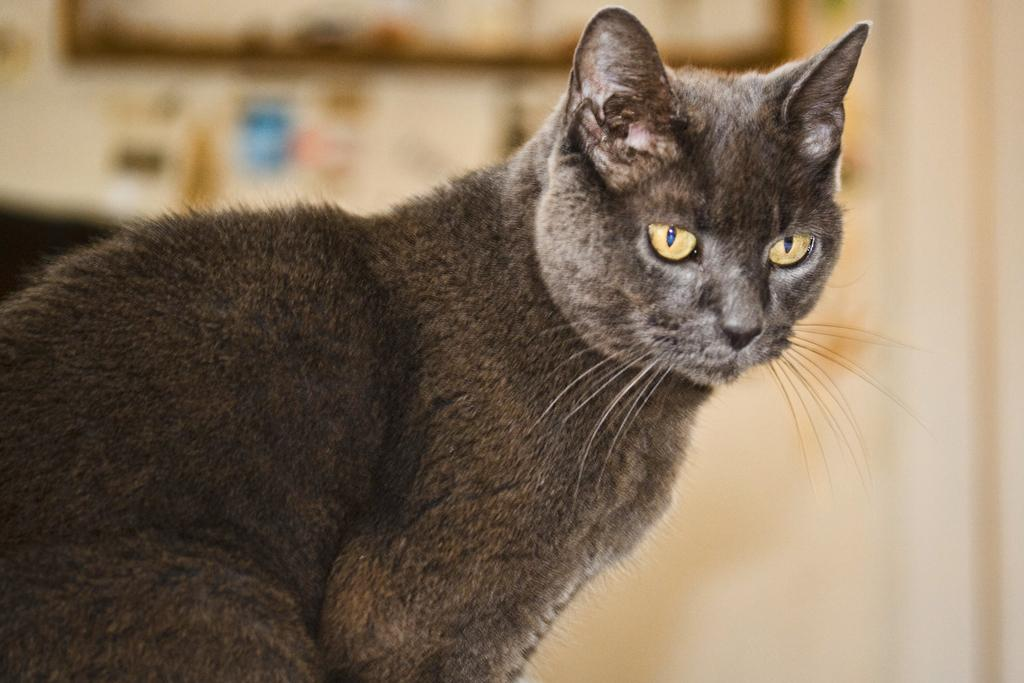What type of animal is in the image? There is a cat in the image. Can you describe the background of the image? The background of the image is blurred. What is the price of the beef in the image? There is no beef present in the image, so it is not possible to determine its price. 